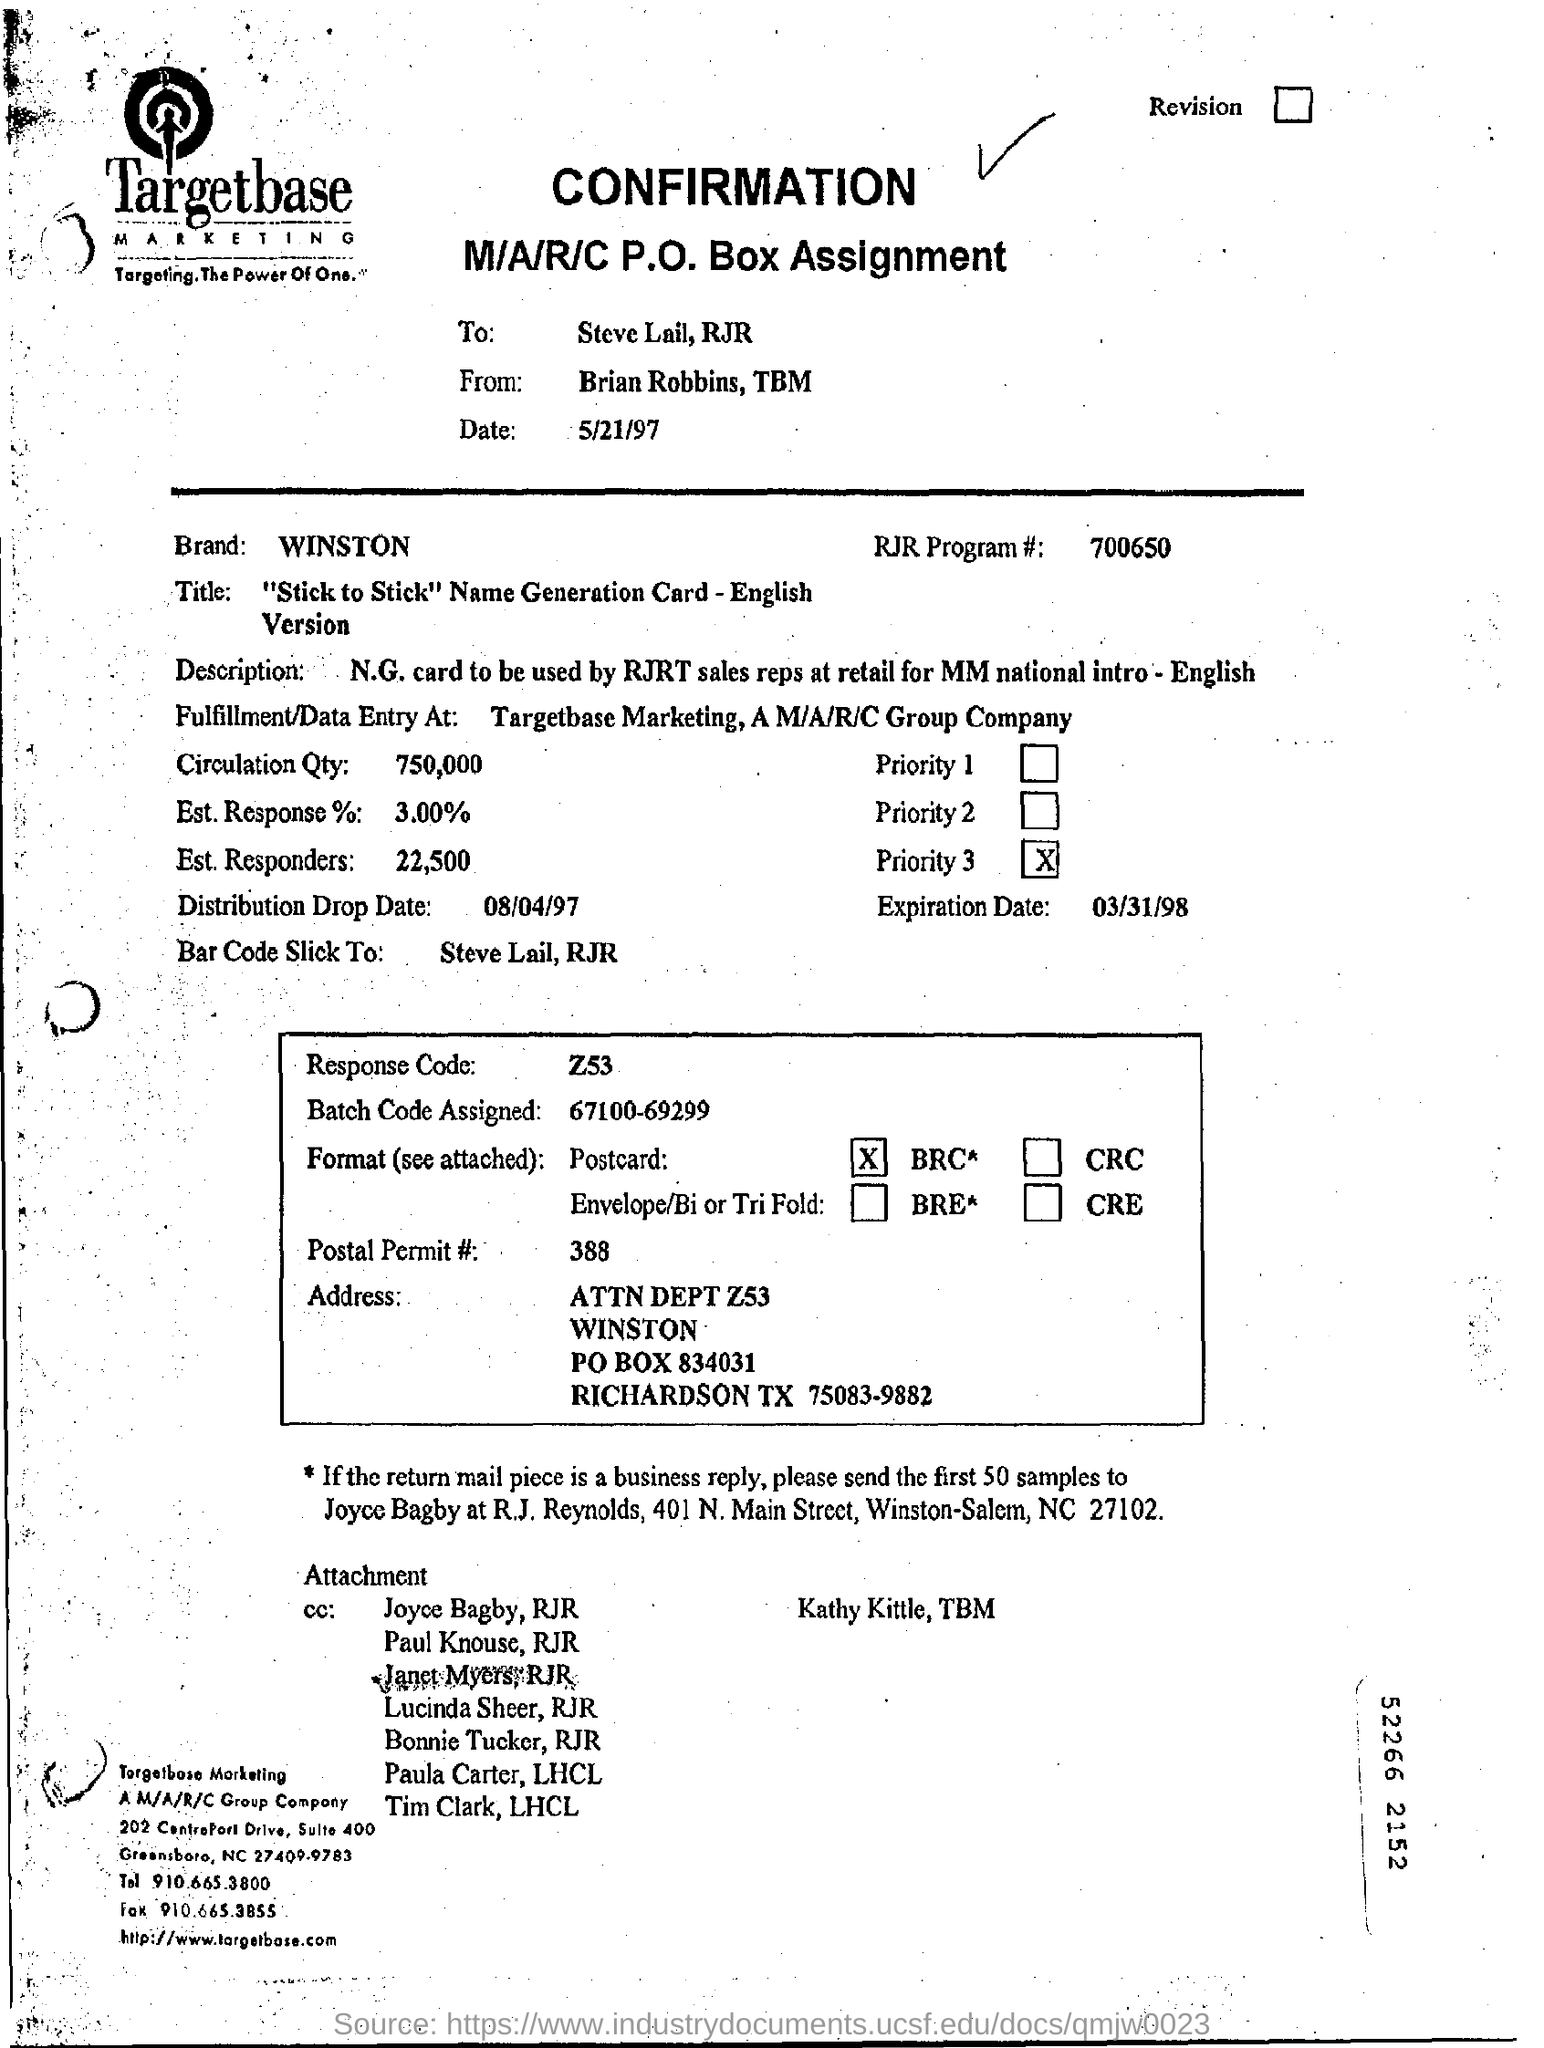Specify some key components in this picture. The distribution drop date is August 4, 1997. The number of the RJR program is 700650... The fulfillment and data entry position is located at Targetbase Marketing, a subsidiary of the M/A/R/C Group. 